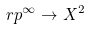<formula> <loc_0><loc_0><loc_500><loc_500>\ r p ^ { \infty } \to X ^ { 2 }</formula> 